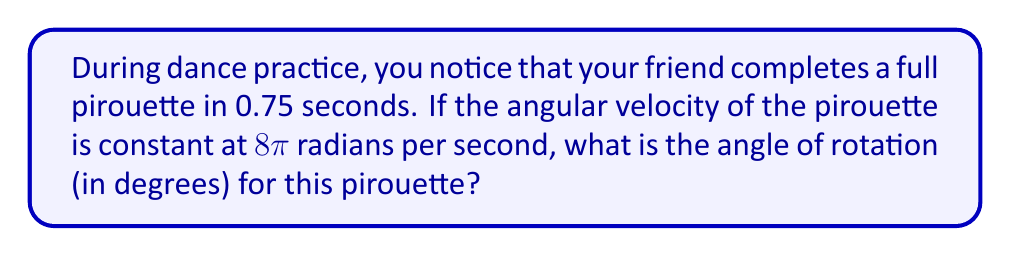Help me with this question. Let's approach this step-by-step:

1) First, we need to understand what we're given:
   - Time of pirouette (t) = 0.75 seconds
   - Angular velocity (ω) = $8\pi$ radians per second

2) We know that the angle of rotation (θ) is related to angular velocity (ω) and time (t) by the formula:
   $$ \theta = \omega t $$

3) Let's substitute our known values:
   $$ \theta = 8\pi \cdot 0.75 $$

4) Simplify:
   $$ \theta = 6\pi \text{ radians} $$

5) Now, we need to convert this to degrees. We know that $2\pi$ radians = 360°, so:
   $$ \frac{\theta}{2\pi} = \frac{x}{360} $$
   where x is the angle in degrees.

6) Substitute our value for θ:
   $$ \frac{6\pi}{2\pi} = \frac{x}{360} $$

7) Simplify:
   $$ 3 = \frac{x}{360} $$

8) Solve for x:
   $$ x = 3 \cdot 360 = 1080 $$

Therefore, the angle of rotation is 1080°.
Answer: 1080° 